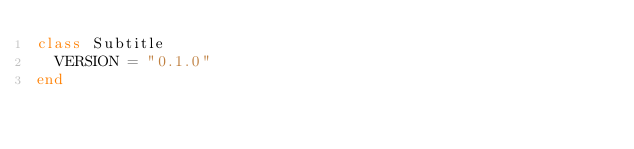<code> <loc_0><loc_0><loc_500><loc_500><_Ruby_>class Subtitle
  VERSION = "0.1.0"
end
</code> 